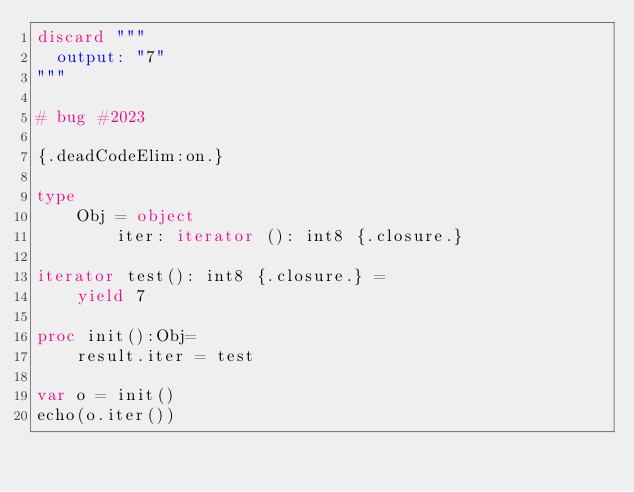Convert code to text. <code><loc_0><loc_0><loc_500><loc_500><_Nim_>discard """
  output: "7"
"""

# bug #2023

{.deadCodeElim:on.}

type
    Obj = object
        iter: iterator (): int8 {.closure.}

iterator test(): int8 {.closure.} =
    yield 7

proc init():Obj=
    result.iter = test

var o = init()
echo(o.iter())
</code> 